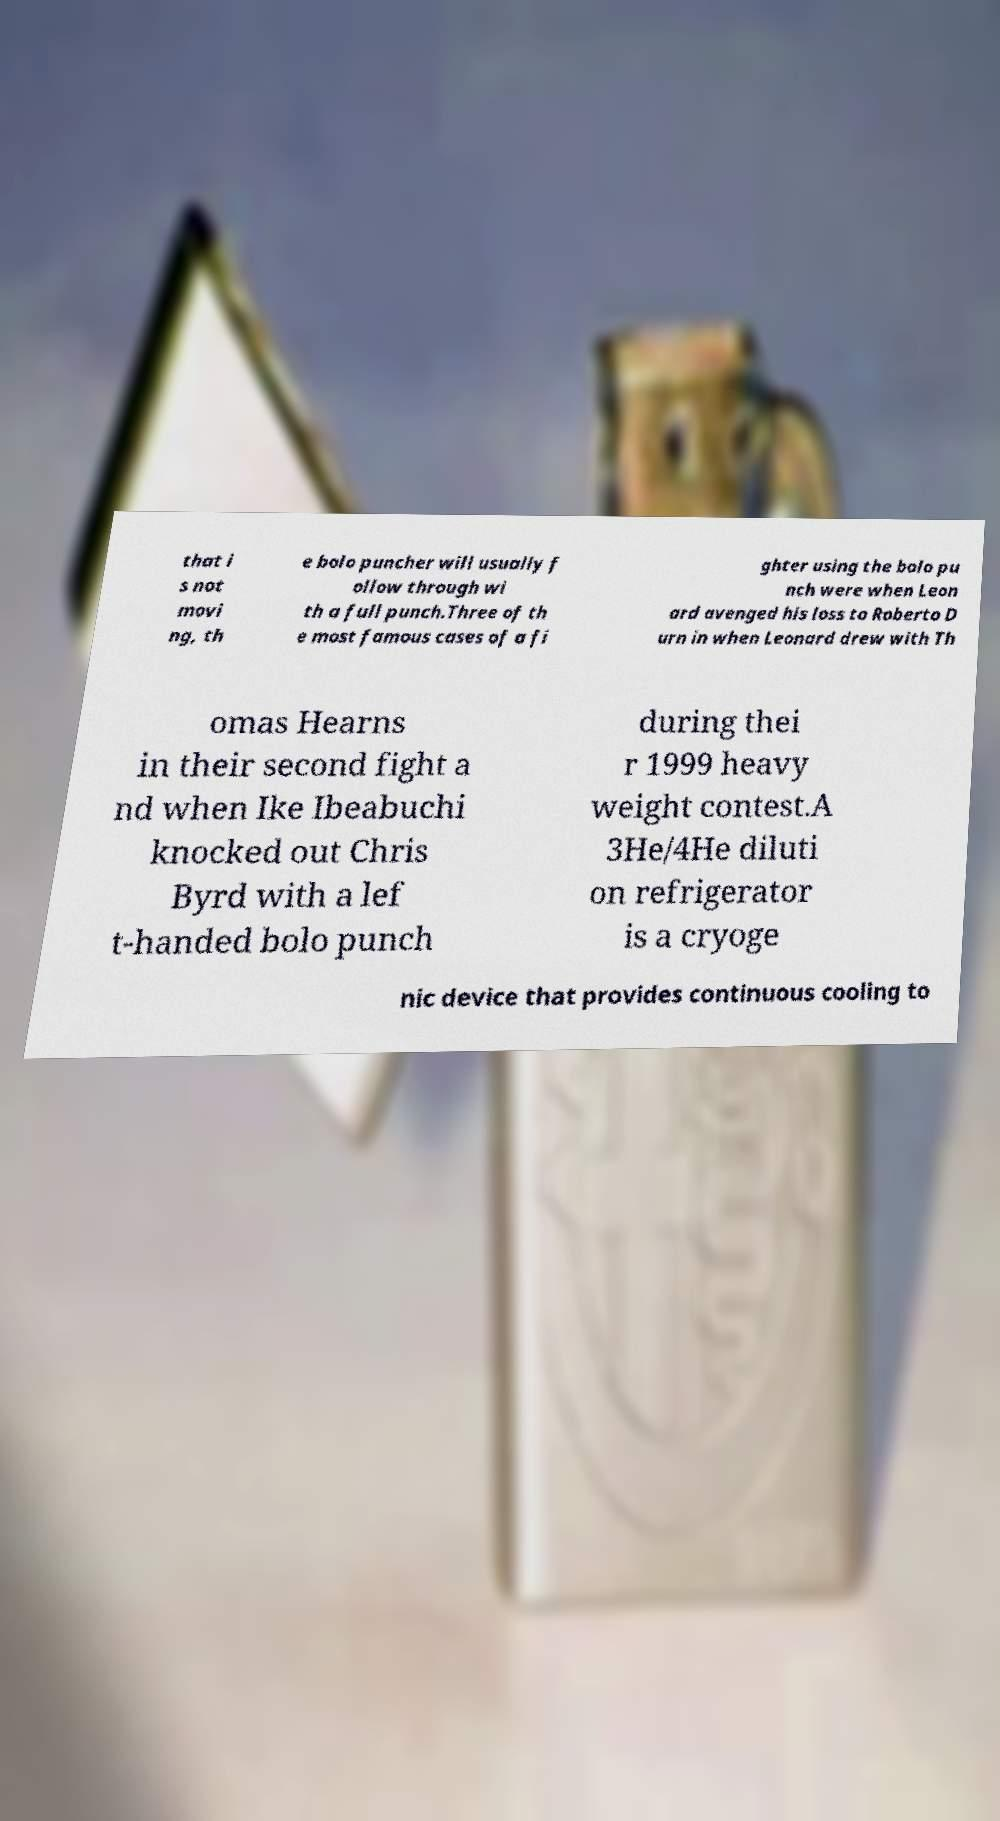Could you extract and type out the text from this image? that i s not movi ng, th e bolo puncher will usually f ollow through wi th a full punch.Three of th e most famous cases of a fi ghter using the bolo pu nch were when Leon ard avenged his loss to Roberto D urn in when Leonard drew with Th omas Hearns in their second fight a nd when Ike Ibeabuchi knocked out Chris Byrd with a lef t-handed bolo punch during thei r 1999 heavy weight contest.A 3He/4He diluti on refrigerator is a cryoge nic device that provides continuous cooling to 